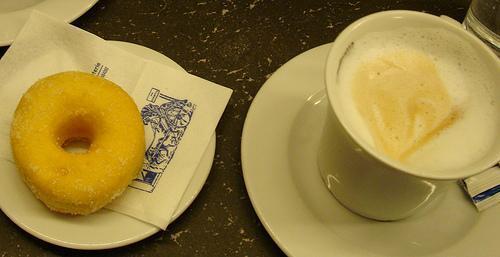How many donuts are there?
Give a very brief answer. 1. 